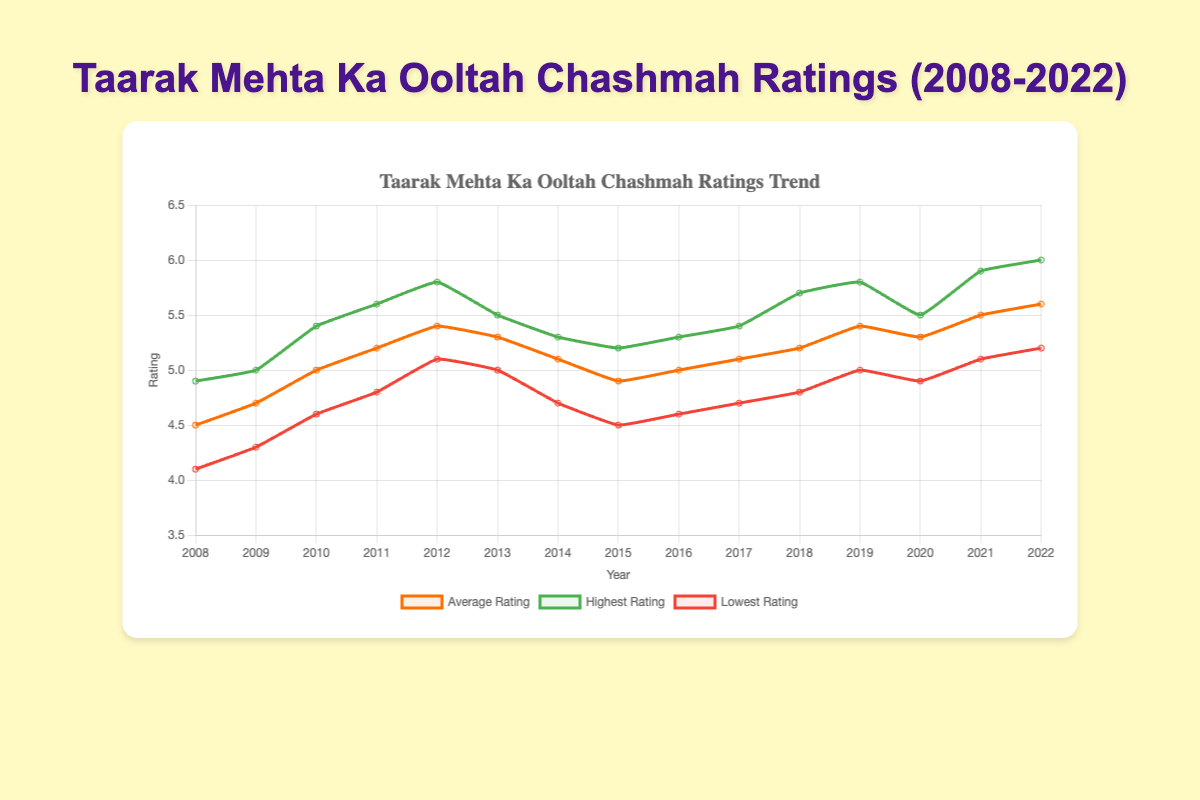What was the highest rating in 2022? To find the highest rating in 2022, look for the data point labeled "2022" under the "HighestRating" category in the plot. The value is around 6.0.
Answer: 6.0 How did the average rating change from 2008 to 2012? To determine the change, subtract the average rating in 2008 from the average rating in 2012. The values are 4.5 in 2008 and 5.4 in 2012, so the change is 5.4 - 4.5 = 0.9.
Answer: 0.9 In which year did the lowest rating first reach 5.0? Look at the plot for the "Lowest Rating" category and find the year where it first reaches 5.0. This occurs in 2012.
Answer: 2012 What is the trend of the average ratings from 2015 to 2018? Examine the "Average Rating" line from 2015 to 2018. The values are 4.9 in 2015, 5.0 in 2016, 5.1 in 2017, and 5.2 in 2018. The trend is an increasing pattern.
Answer: Increasing What is the average of the highest ratings in 2011 and 2021? To calculate the average, add the highest ratings for 2011 and 2021 and divide by 2. The values are 5.6 for 2011 and 5.9 for 2021, so the calculation is (5.6 + 5.9) / 2 = 5.75.
Answer: 5.75 Which year's lowest rating was closest to the highest rating of the previous year? Compare each year's lowest rating with the highest rating of the previous year. Identify the pair with the smallest difference. The lowest rating of 2013 (5.0) is closest to the highest rating of 2012 (5.8).
Answer: 2013 By how much did the highest rating increase from 2020 to 2022? Find the difference between the highest ratings in 2020 (5.5) and 2022 (6.0). The increase is 6.0 - 5.5 = 0.5.
Answer: 0.5 Which year experienced the highest drop in average rating compared to the previous year? Calculate the drops between consecutive years and identify the year with the largest decrease. The drops are calculated as follows:
2014-2013: 5.1 - 5.3 = -0.2,
2015-2014: 4.9 - 5.1 = -0.2
Therefore, the highest drop is 0.2, which occurred in 2014.
Answer: 2014 In which year was the range of ratings (highest - lowest) the smallest? Calculate the range for each year by subtracting the lowest rating from the highest rating and find the year with the smallest value. For example:
2008: 4.9 - 4.1 = 0.8,
2009: 5.0 - 4.3 = 0.7,
...
The smallest range is in 2013 (5.5 - 5.0 = 0.5).
Answer: 2013 